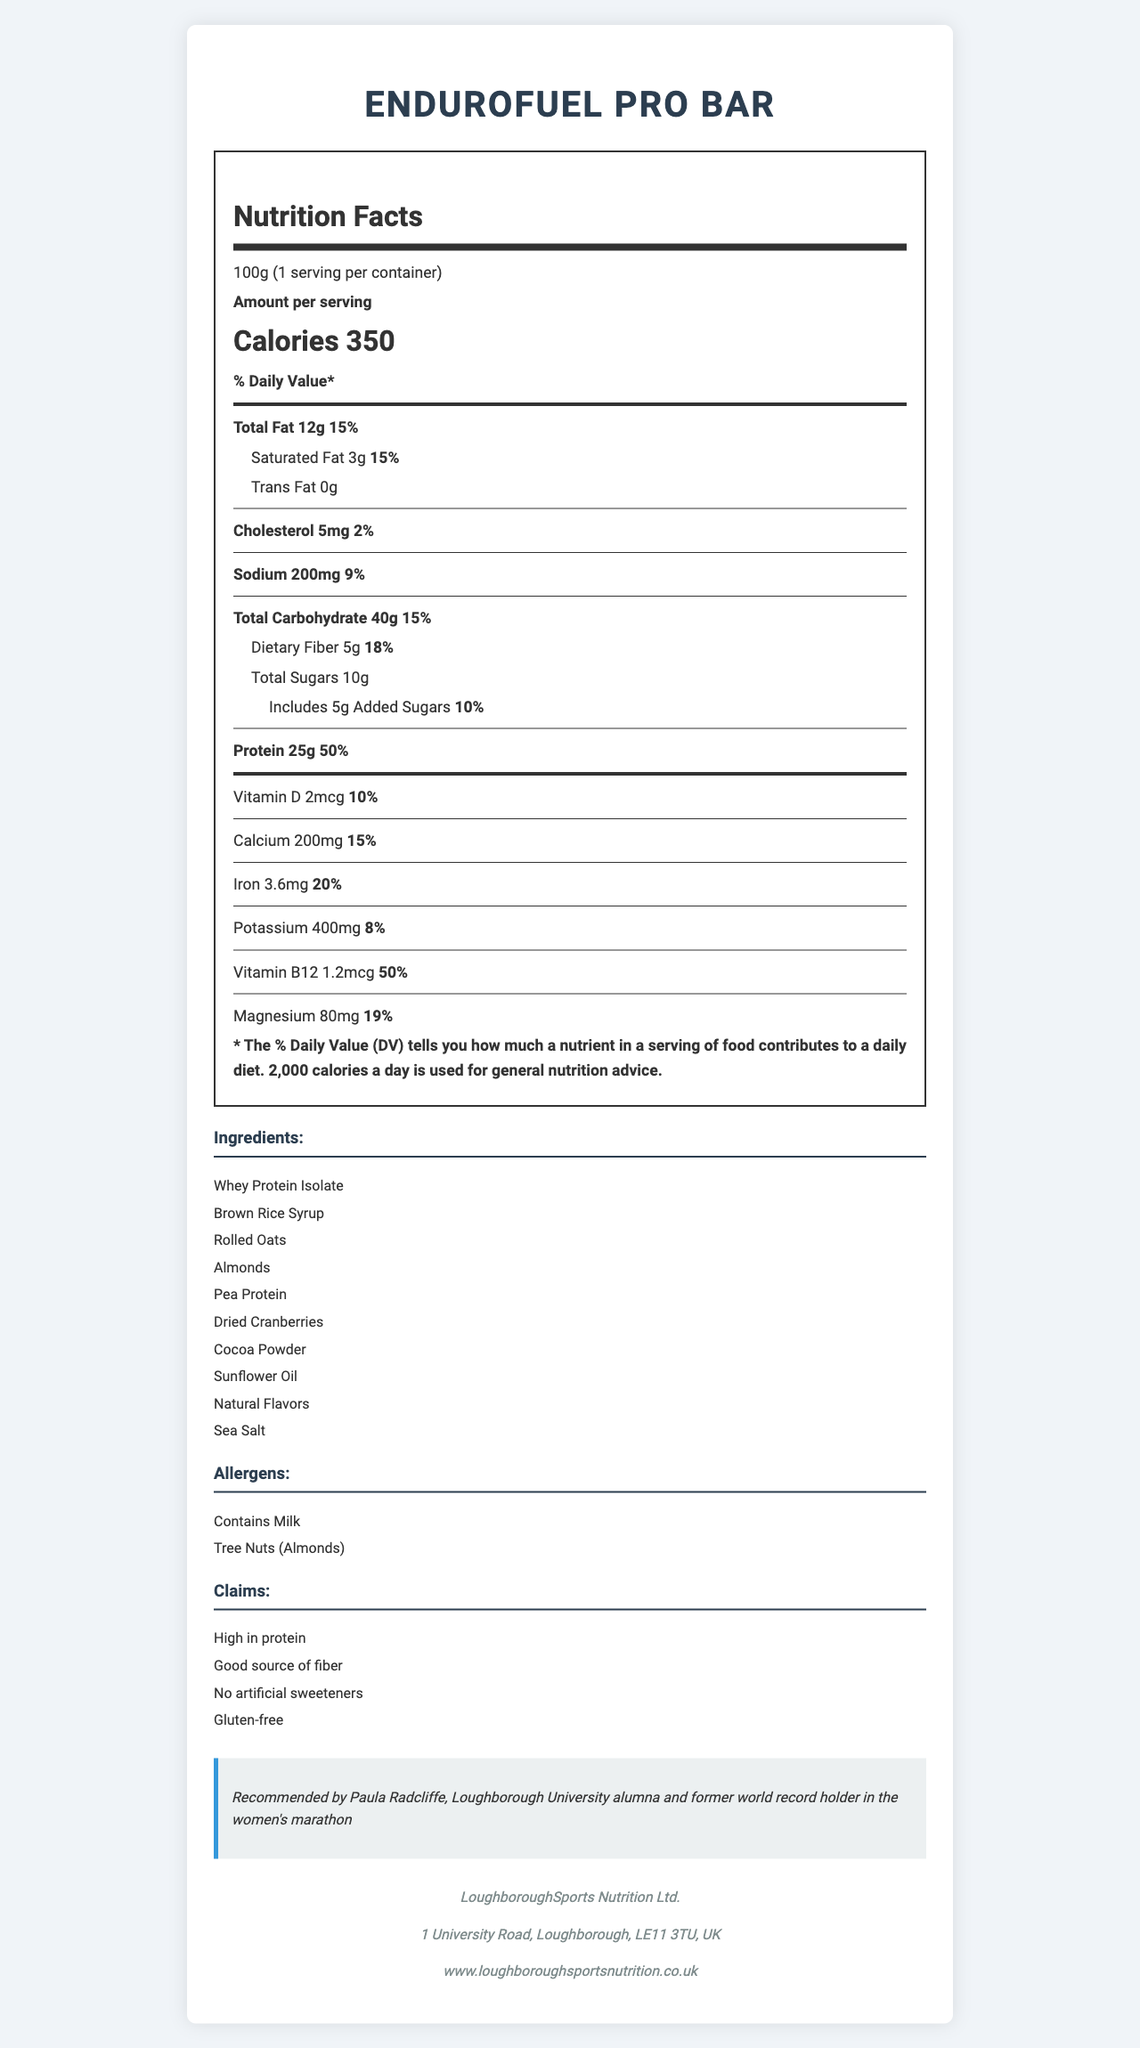what is the serving size of the EnduroFuel Pro Bar? The serving size is clearly indicated at the beginning of the document as "Serving Size: 100g".
Answer: 100g how many calories does one serving contain? The document states directly under "Amount per serving" that the calories per serving are 350.
Answer: 350 how much protein does the bar provide? The amount of protein is listed in the nutritional information as 25g.
Answer: 25g what are the primary ingredients of the EnduroFuel Pro Bar? These ingredients are listed at the top of the ingredients section.
Answer: Whey Protein Isolate, Brown Rice Syrup, Rolled Oats, Almonds, Pea Protein what is the percent daily value of dietary fiber in the bar? The document indicates under "Dietary Fiber" that the percent daily value is 18%.
Answer: 18% which nutrient has the highest percent daily value and what is it? A. Calcium B. Iron C. Protein The percent daily value (DV) for protein is the highest at 50%.
Answer: C what is the amount of sodium in the EnduroFuel Pro Bar? 1. 100mg 2. 200mg 3. 300mg 4. 400mg The document lists the amount of sodium as 200mg.
Answer: 2 is the EnduroFuel Pro Bar gluten-free? The claims section lists "Gluten-free" as one of the product claims.
Answer: Yes how much added sugar is in the EnduroFuel Pro Bar? The amount of added sugars is specified in the nutrition label.
Answer: 5g are there any allergens in the EnduroFuel Pro Bar? If so, what are they? The allergens section lists "Contains Milk" and "Tree Nuts (Almonds)".
Answer: Yes, Milk and Tree Nuts (Almonds) describe the main idea of the document. The document is styled to present comprehensive information about the EnduroFuel Pro Bar, including its nutritional values, ingredients, ownership and endorsements, aimed at informing potential consumers about its benefits and contents.
Answer: The document provides detailed nutritional information about the EnduroFuel Pro Bar, a high-protein meal replacement bar targeting endurance athletes. It lists the nutritional content, ingredients, allergens, product claims, manufacturer info, and an endorsement by Paula Radcliffe. can the exact amount of natural flavors in the bar be determined? The document lists "Natural Flavors" as an ingredient but does not specify the exact amount.
Answer: Not enough information how much Vitamin D is in the bar and what percentage of the daily value does this represent? The nutrition label states that the bar has 2mcg of Vitamin D, amounting to 10% of the daily value.
Answer: 2mcg, 10% how many servings are contained in one package of the EnduroFuel Pro Bar? The document specifies that there is 1 serving per container.
Answer: 1 what claim is endorsed by Paula Radcliffe? The athlete endorsement section states that Paula Radcliffe recommends the product and highlights her credentials.
Answer: Recommended by Paula Radcliffe, Loughborough University alumna and former world record holder in the women's marathon 